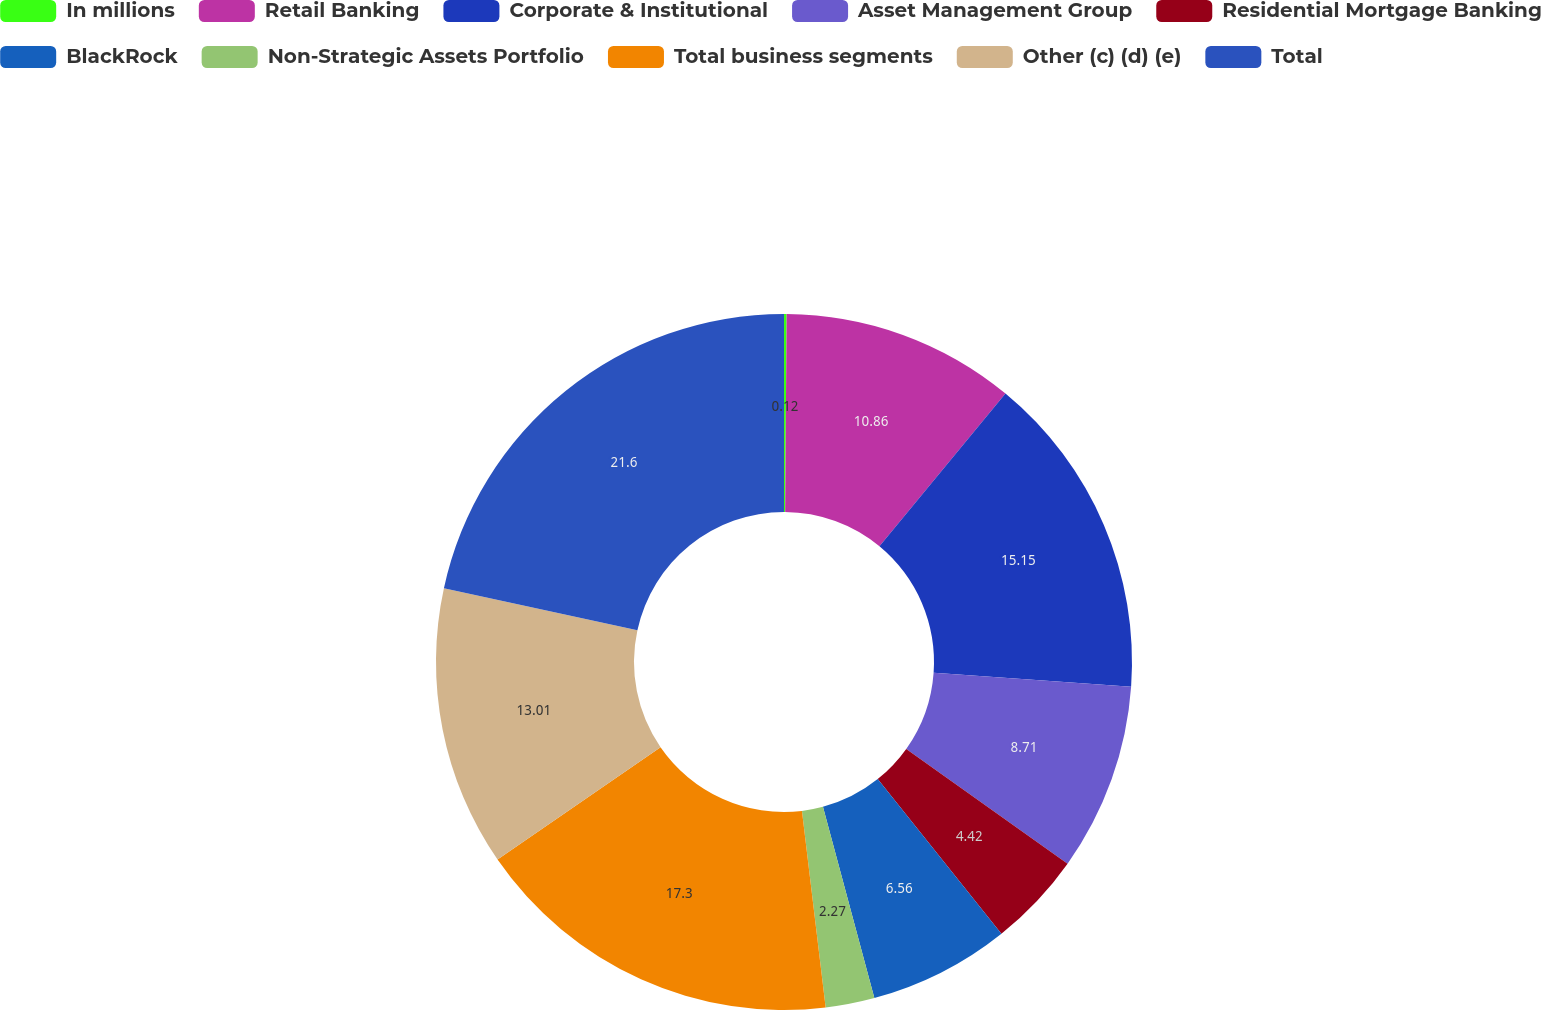<chart> <loc_0><loc_0><loc_500><loc_500><pie_chart><fcel>In millions<fcel>Retail Banking<fcel>Corporate & Institutional<fcel>Asset Management Group<fcel>Residential Mortgage Banking<fcel>BlackRock<fcel>Non-Strategic Assets Portfolio<fcel>Total business segments<fcel>Other (c) (d) (e)<fcel>Total<nl><fcel>0.12%<fcel>10.86%<fcel>15.15%<fcel>8.71%<fcel>4.42%<fcel>6.56%<fcel>2.27%<fcel>17.3%<fcel>13.01%<fcel>21.6%<nl></chart> 